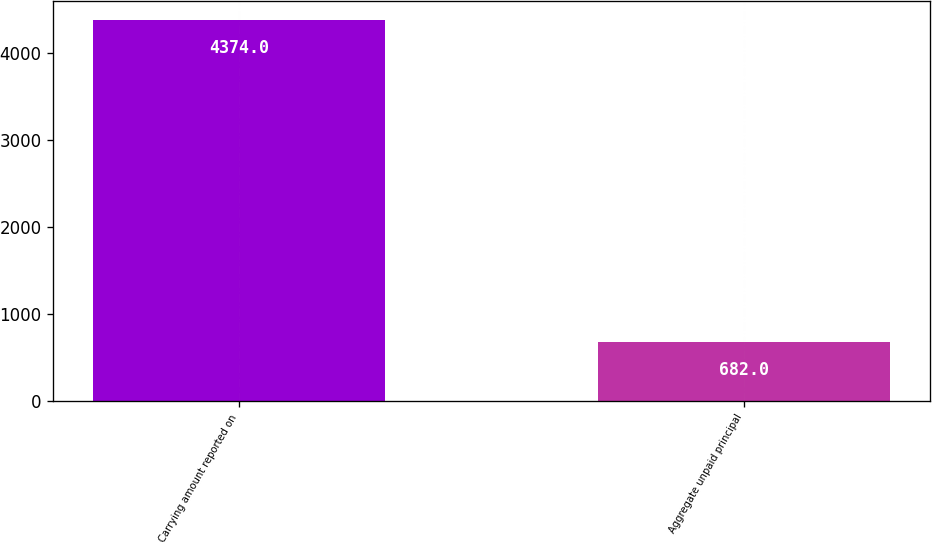Convert chart. <chart><loc_0><loc_0><loc_500><loc_500><bar_chart><fcel>Carrying amount reported on<fcel>Aggregate unpaid principal<nl><fcel>4374<fcel>682<nl></chart> 